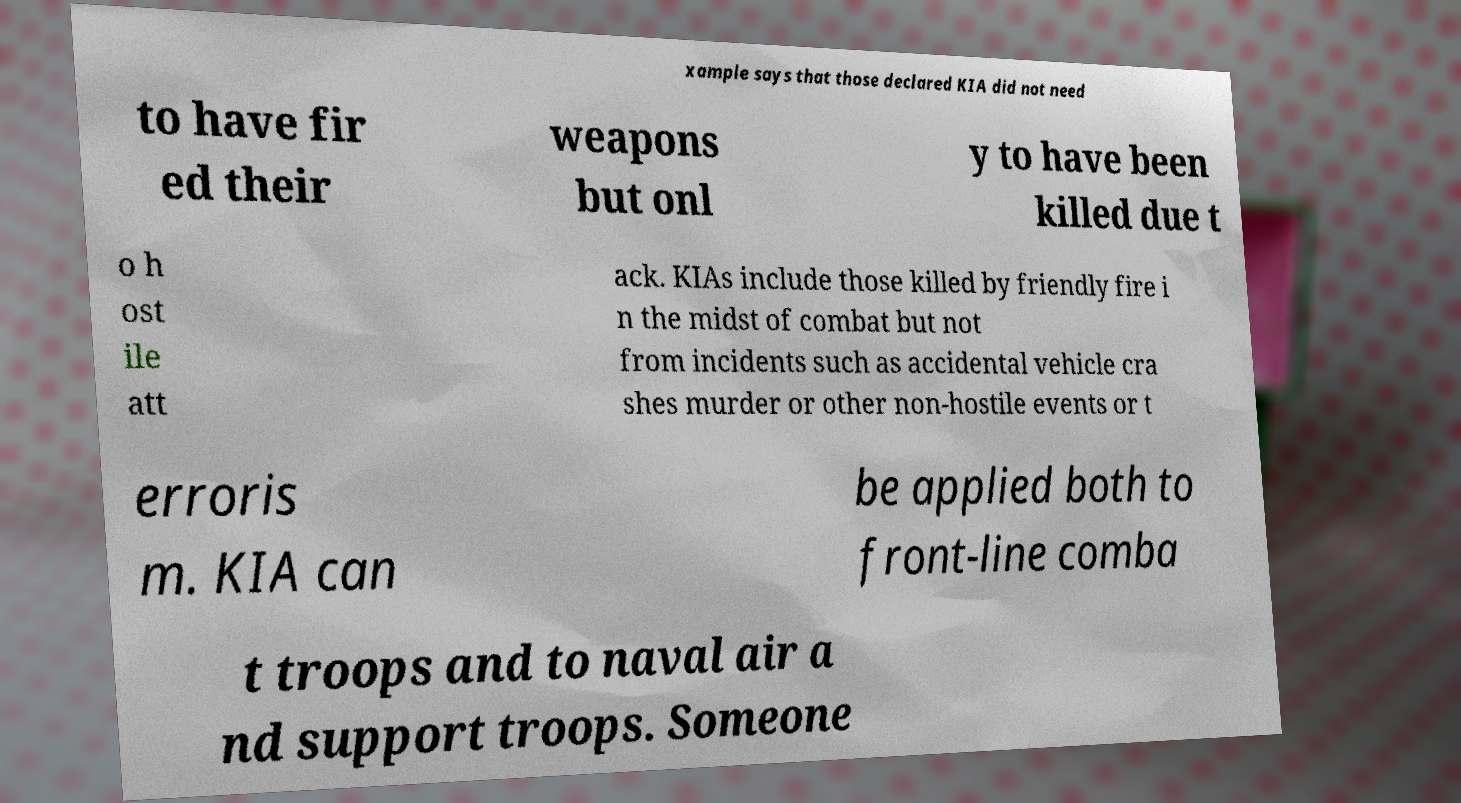Could you assist in decoding the text presented in this image and type it out clearly? xample says that those declared KIA did not need to have fir ed their weapons but onl y to have been killed due t o h ost ile att ack. KIAs include those killed by friendly fire i n the midst of combat but not from incidents such as accidental vehicle cra shes murder or other non-hostile events or t erroris m. KIA can be applied both to front-line comba t troops and to naval air a nd support troops. Someone 